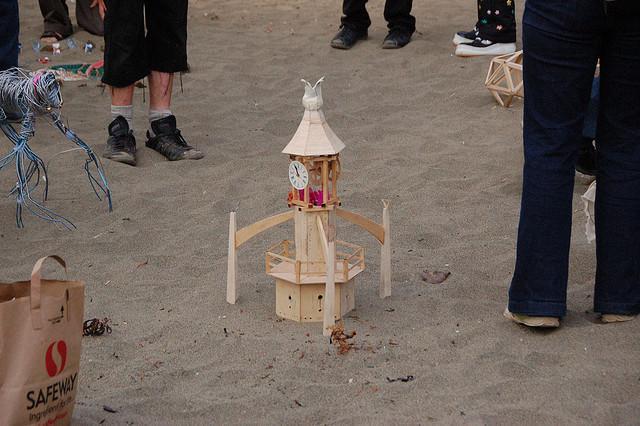How many handbags are in the picture?
Give a very brief answer. 1. How many people are there?
Give a very brief answer. 4. 